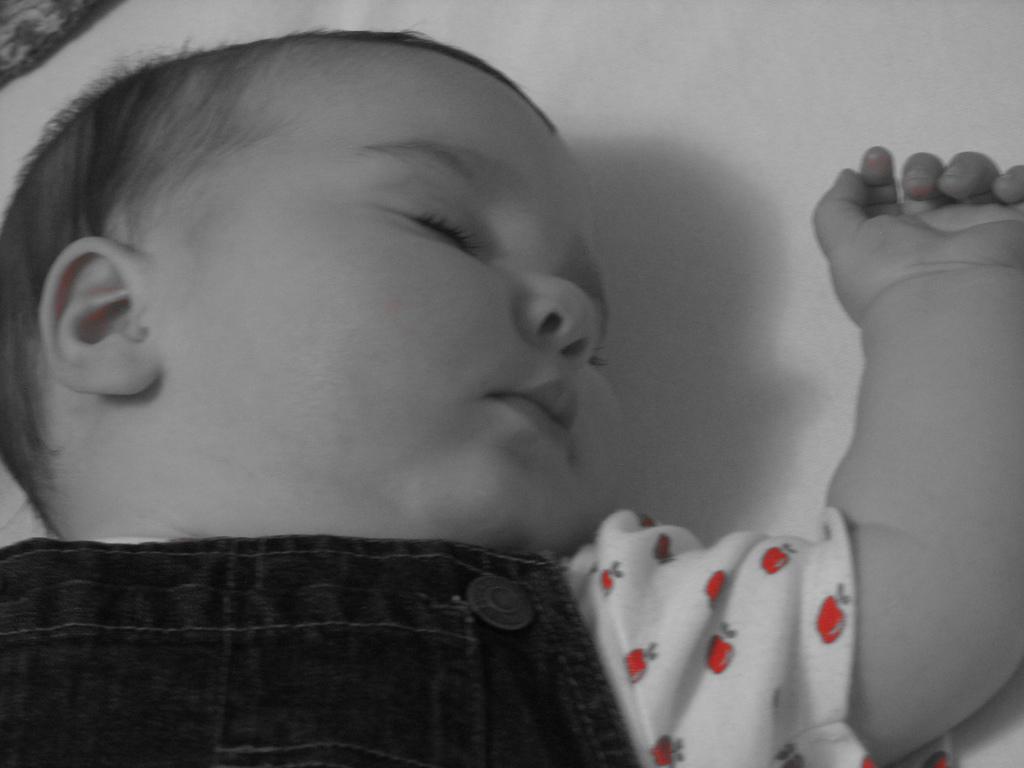Describe this image in one or two sentences. In this picture we can see a baby sleeping on a white cloth. 